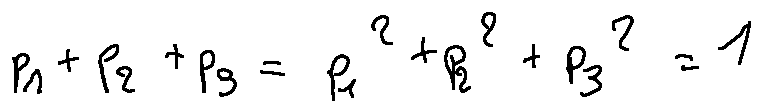<formula> <loc_0><loc_0><loc_500><loc_500>p _ { 1 } + p _ { 2 } + p _ { 3 } = p _ { 1 } ^ { 2 } + p _ { 2 } ^ { 2 } + p _ { 3 } ^ { 2 } = 1</formula> 